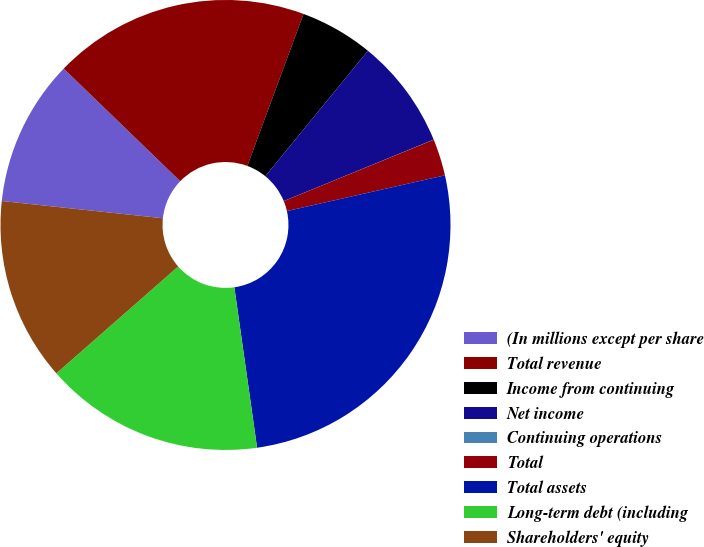<chart> <loc_0><loc_0><loc_500><loc_500><pie_chart><fcel>(In millions except per share<fcel>Total revenue<fcel>Income from continuing<fcel>Net income<fcel>Continuing operations<fcel>Total<fcel>Total assets<fcel>Long-term debt (including<fcel>Shareholders' equity<nl><fcel>10.53%<fcel>18.41%<fcel>5.27%<fcel>7.9%<fcel>0.01%<fcel>2.64%<fcel>26.3%<fcel>15.78%<fcel>13.16%<nl></chart> 